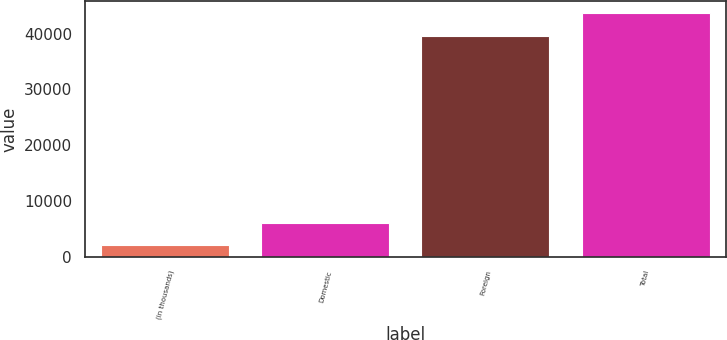Convert chart to OTSL. <chart><loc_0><loc_0><loc_500><loc_500><bar_chart><fcel>(in thousands)<fcel>Domestic<fcel>Foreign<fcel>Total<nl><fcel>2002<fcel>6061.7<fcel>39532<fcel>43591.7<nl></chart> 